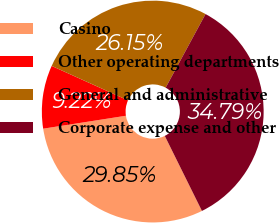<chart> <loc_0><loc_0><loc_500><loc_500><pie_chart><fcel>Casino<fcel>Other operating departments<fcel>General and administrative<fcel>Corporate expense and other<nl><fcel>29.85%<fcel>9.22%<fcel>26.15%<fcel>34.79%<nl></chart> 